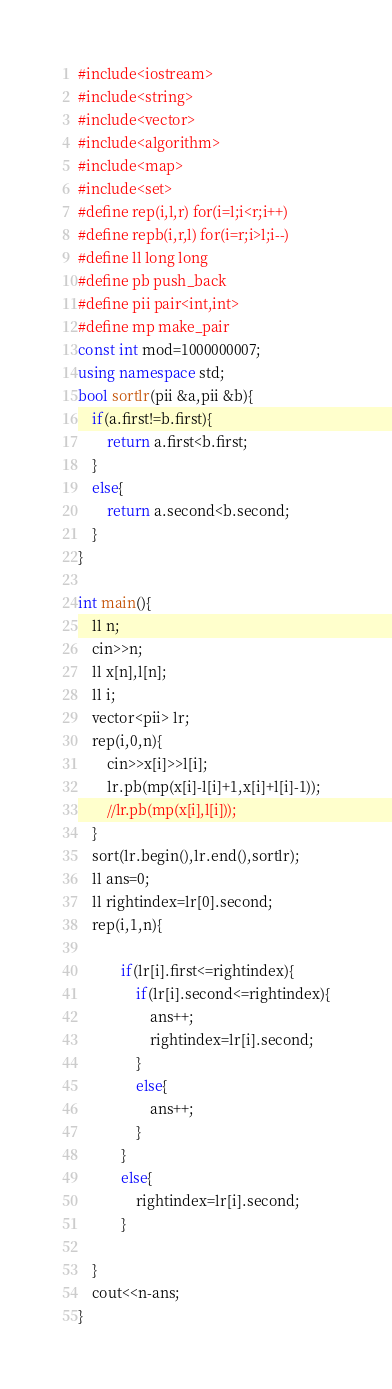<code> <loc_0><loc_0><loc_500><loc_500><_C++_>#include<iostream>
#include<string>
#include<vector>
#include<algorithm>
#include<map>
#include<set>
#define rep(i,l,r) for(i=l;i<r;i++)
#define repb(i,r,l) for(i=r;i>l;i--)
#define ll long long
#define pb push_back
#define pii pair<int,int>
#define mp make_pair
const int mod=1000000007;
using namespace std;
bool sortlr(pii &a,pii &b){
    if(a.first!=b.first){
        return a.first<b.first;
    }
    else{
        return a.second<b.second;
    }
}

int main(){
    ll n;
    cin>>n;
    ll x[n],l[n];
    ll i;
    vector<pii> lr;
    rep(i,0,n){
        cin>>x[i]>>l[i];
        lr.pb(mp(x[i]-l[i]+1,x[i]+l[i]-1));
        //lr.pb(mp(x[i],l[i]));
    }
    sort(lr.begin(),lr.end(),sortlr);
    ll ans=0;
    ll rightindex=lr[0].second;
    rep(i,1,n){
        
            if(lr[i].first<=rightindex){
                if(lr[i].second<=rightindex){
                    ans++;
                    rightindex=lr[i].second;
                }
                else{
                    ans++;
                }
            }
            else{
                rightindex=lr[i].second;
            }
        
    }
    cout<<n-ans;
}

</code> 